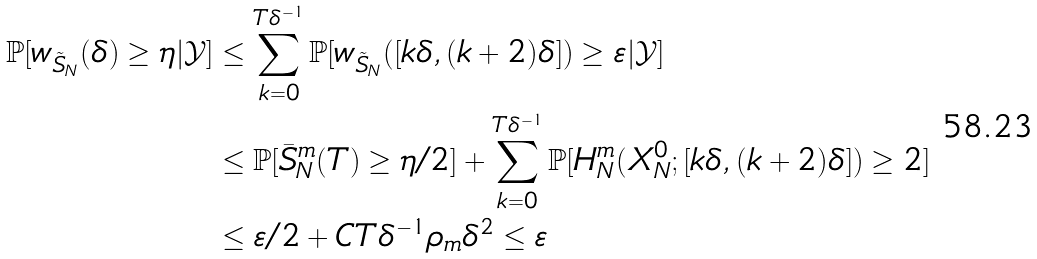<formula> <loc_0><loc_0><loc_500><loc_500>\mathbb { P } [ w _ { \tilde { S } _ { N } } ( \delta ) \geq \eta | \mathcal { Y } ] & \leq \sum _ { k = 0 } ^ { T \delta ^ { - 1 } } \mathbb { P } [ w _ { \tilde { S } _ { N } } ( [ k \delta , ( k + 2 ) \delta ] ) \geq \varepsilon | \mathcal { Y } ] \\ & \leq \mathbb { P } [ \bar { S } ^ { m } _ { N } ( T ) \geq \eta / 2 ] + \sum _ { k = 0 } ^ { T \delta ^ { - 1 } } \mathbb { P } [ H ^ { m } _ { N } ( X ^ { 0 } _ { N } ; [ k \delta , ( k + 2 ) \delta ] ) \geq 2 ] \\ & \leq \varepsilon / 2 + C T \delta ^ { - 1 } \rho _ { m } \delta ^ { 2 } \leq \varepsilon</formula> 